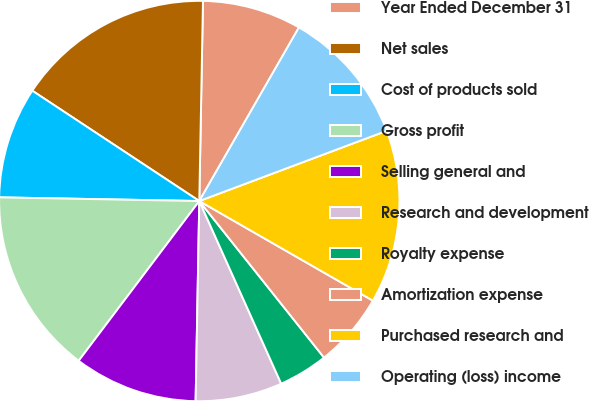Convert chart. <chart><loc_0><loc_0><loc_500><loc_500><pie_chart><fcel>Year Ended December 31<fcel>Net sales<fcel>Cost of products sold<fcel>Gross profit<fcel>Selling general and<fcel>Research and development<fcel>Royalty expense<fcel>Amortization expense<fcel>Purchased research and<fcel>Operating (loss) income<nl><fcel>8.0%<fcel>16.0%<fcel>9.0%<fcel>15.0%<fcel>10.0%<fcel>7.0%<fcel>4.0%<fcel>6.0%<fcel>14.0%<fcel>11.0%<nl></chart> 